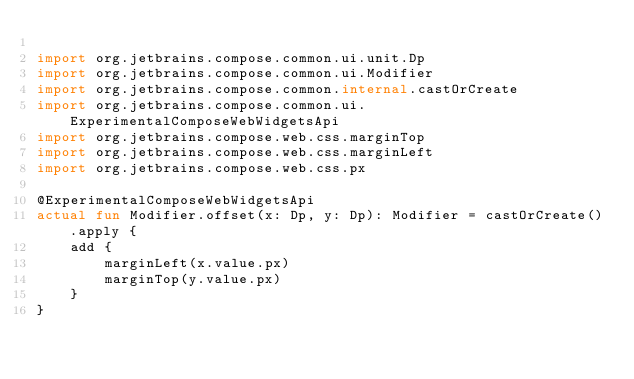<code> <loc_0><loc_0><loc_500><loc_500><_Kotlin_>
import org.jetbrains.compose.common.ui.unit.Dp
import org.jetbrains.compose.common.ui.Modifier
import org.jetbrains.compose.common.internal.castOrCreate
import org.jetbrains.compose.common.ui.ExperimentalComposeWebWidgetsApi
import org.jetbrains.compose.web.css.marginTop
import org.jetbrains.compose.web.css.marginLeft
import org.jetbrains.compose.web.css.px

@ExperimentalComposeWebWidgetsApi
actual fun Modifier.offset(x: Dp, y: Dp): Modifier = castOrCreate().apply {
    add {
        marginLeft(x.value.px)
        marginTop(y.value.px)
    }
}
</code> 